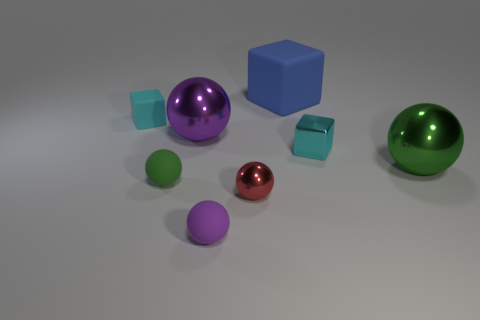What materials do the objects appear to be made of? The objects display a variety of textures and reflective qualities, suggesting they are made of different materials such as plastic, metal, and possibly glass, lending a diverse tactile quality to the scene.  What time of day does the lighting suggest? The soft and even lighting with diffused shadows suggests that it could either be a cloudy day or an indoor setting with ambient lighting, as there are no harsh shadows indicative of direct sunlight. 